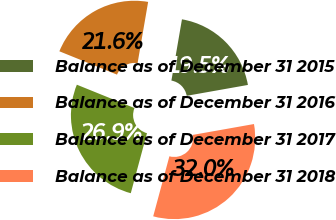Convert chart. <chart><loc_0><loc_0><loc_500><loc_500><pie_chart><fcel>Balance as of December 31 2015<fcel>Balance as of December 31 2016<fcel>Balance as of December 31 2017<fcel>Balance as of December 31 2018<nl><fcel>19.49%<fcel>21.59%<fcel>26.93%<fcel>31.99%<nl></chart> 